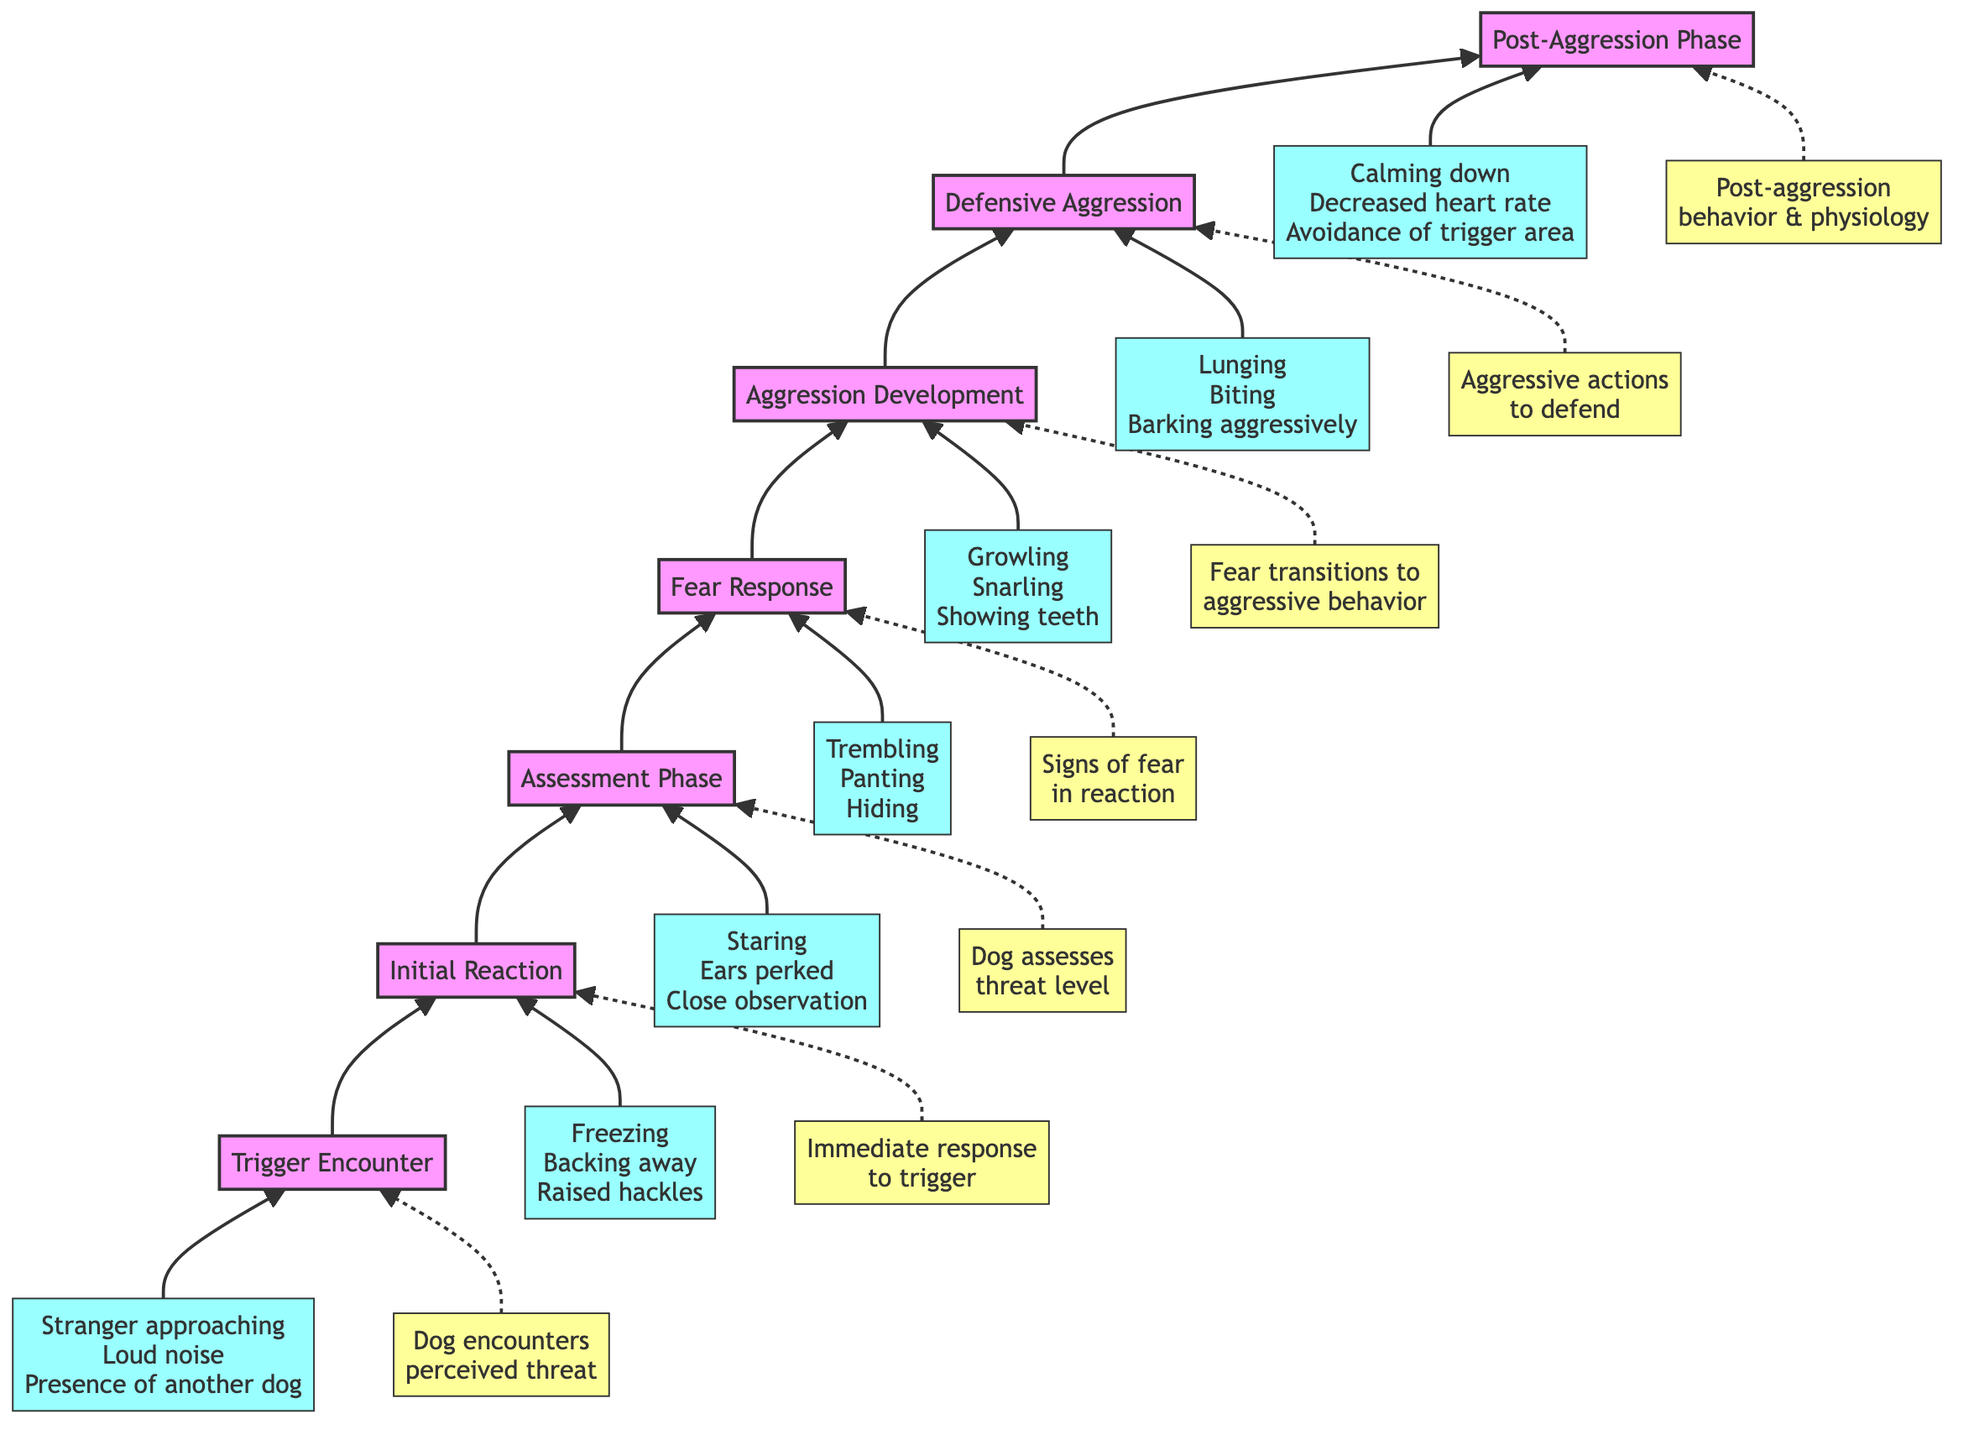What is the first stage of fear-based aggression development in dogs? The diagram indicates that the first stage is "Trigger Encounter", which involves the dog encountering a perceived threat.
Answer: Trigger Encounter What are two examples of triggers listed in the diagram? The diagram provides examples under the "Trigger Encounter" stage, such as "Stranger approaching" and "Loud noise."
Answer: Stranger approaching, Loud noise How many stages are there in the fear-based aggression development process? By counting the stages listed in the diagram, there are a total of seven separate stages from the "Trigger Encounter" to the "Post-Aggression Phase."
Answer: 7 What transition occurs after "Fear Response"? The diagram shows that after the "Fear Response," the next stage is "Aggression Development," indicating a transition from fear to aggression.
Answer: Aggression Development What kind of behavior is exhibited during the "Defensive Aggression" stage? In the "Defensive Aggression" stage, behaviors such as "Lunging", "Biting", and "Barking aggressively" are highlighted as examples.
Answer: Lunging, Biting, Barking aggressively What descriptive term is used for the behavior in the "Post-Aggression Phase"? The diagram describes the behavior in the "Post-Aggression Phase" as a process of "Calming down," which reflects a reduction in aggression following the aggressive response.
Answer: Calming down Which stage involves the dog assessing the threat level? The "Assessment Phase" is the stage that specifically involves the dog evaluating the potential threat level it perceives after encountering the trigger.
Answer: Assessment Phase How does the flow of the diagram move from one stage to the next? The flow of the diagram moves from the lower stages, starting with "Trigger Encounter," upwards through each successive stage, ultimately reaching "Post-Aggression Phase."
Answer: Upwards through each stage 